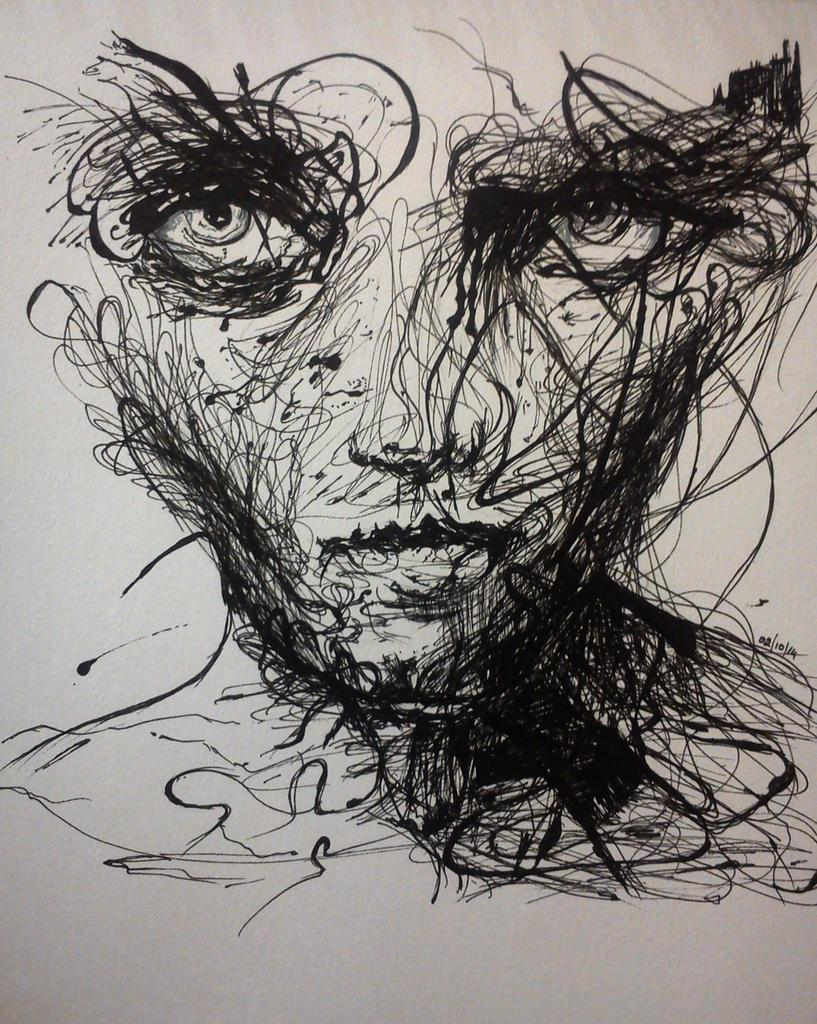What type of artwork is depicted in the image? The image is a painting. Can you describe the main subject of the painting? There is a person in the center of the painting. What type of juice is being served in the jail depicted in the painting? There is no mention of juice or a jail in the painting; it only features a person in the center. 